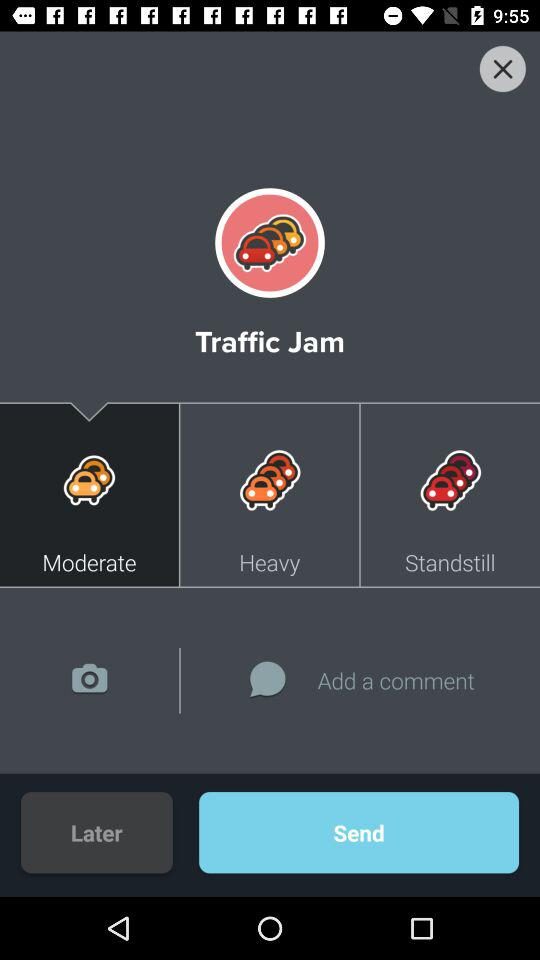What type of "Traffic Jam" is selected? The selected type is "Moderate". 